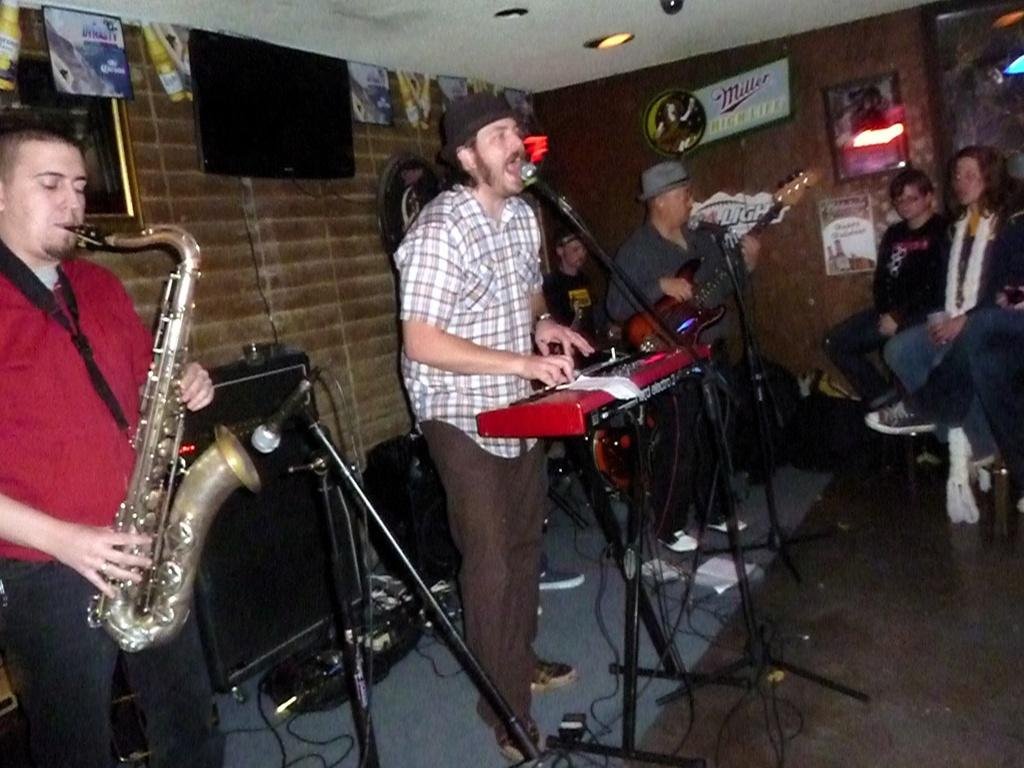How many musicians are playing in the image? There are three people playing musical instruments in the image. What are the people seated doing? The two people seated are watching the musicians. What type of wood is used to make the alarm in the image? There is no alarm present in the image, and therefore no wood is used to make it. 